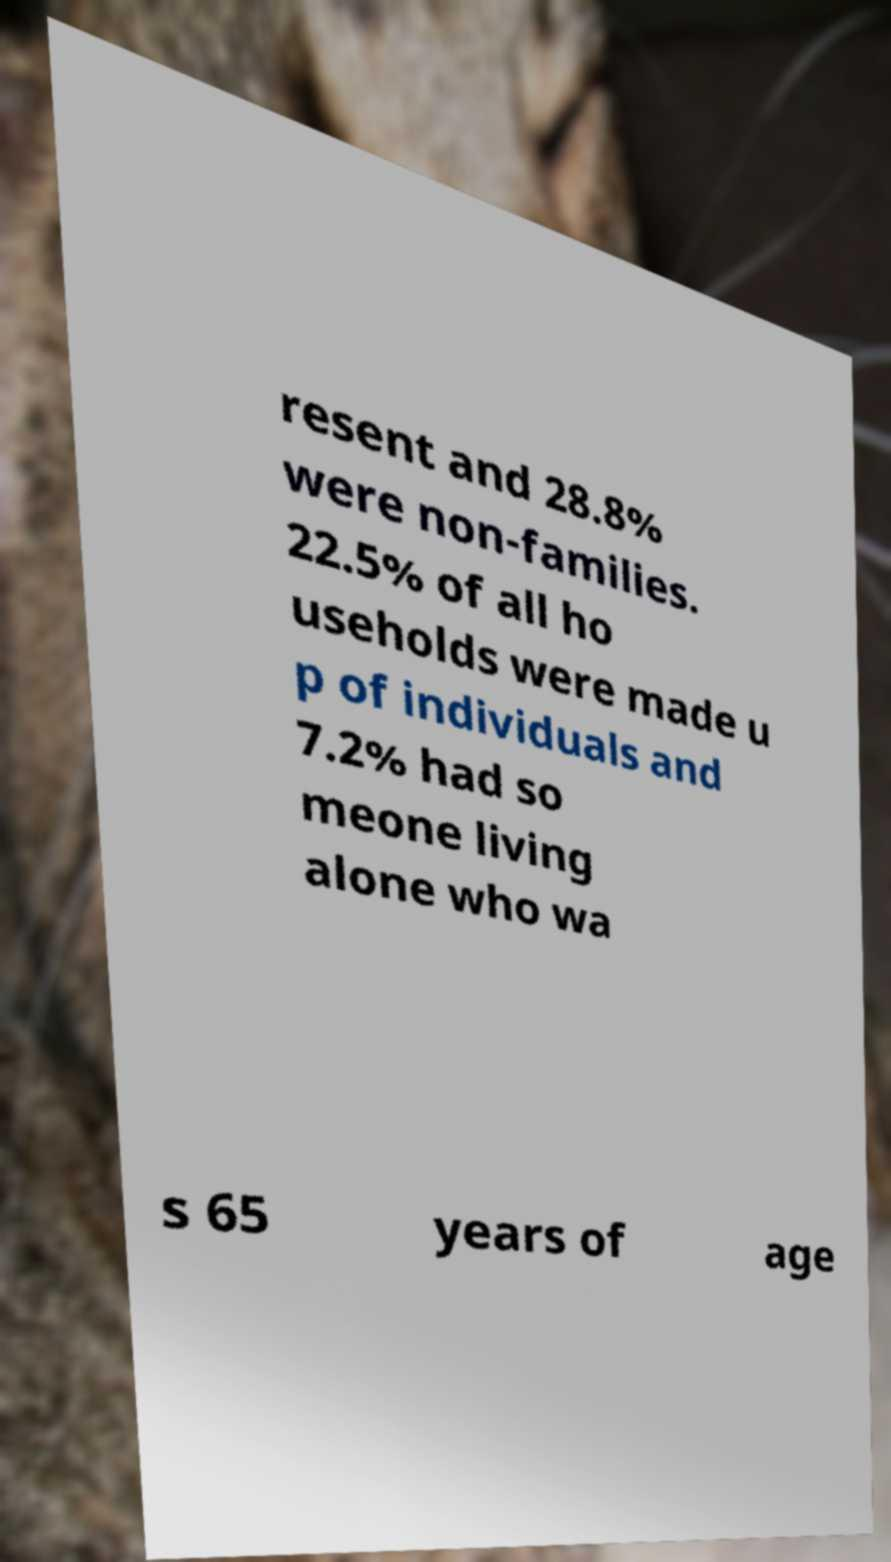What messages or text are displayed in this image? I need them in a readable, typed format. resent and 28.8% were non-families. 22.5% of all ho useholds were made u p of individuals and 7.2% had so meone living alone who wa s 65 years of age 